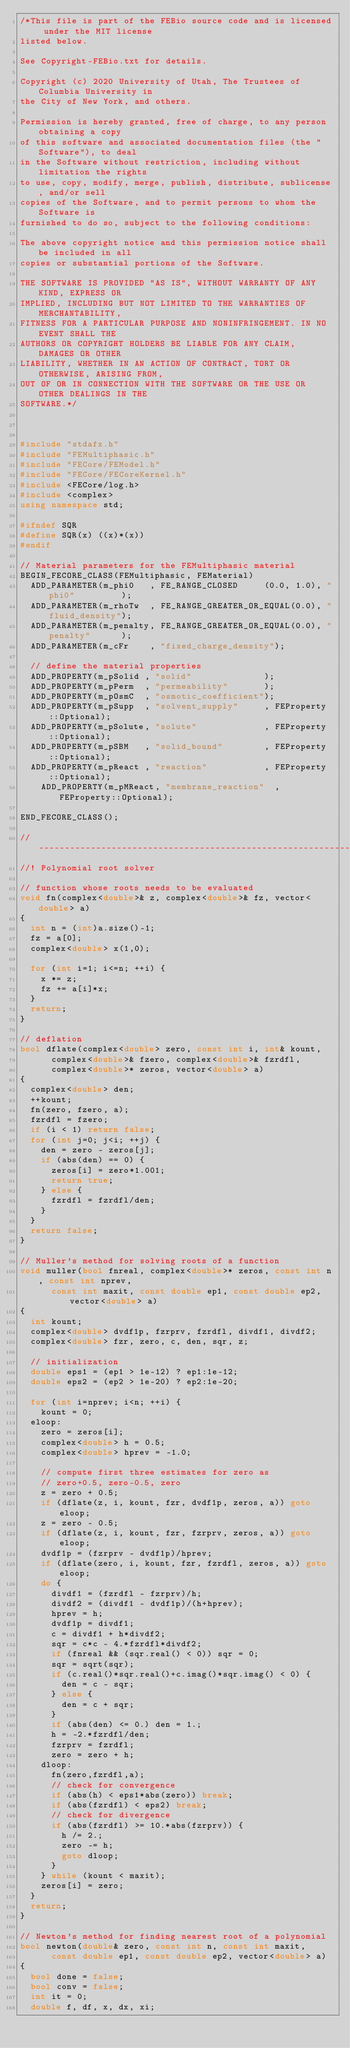<code> <loc_0><loc_0><loc_500><loc_500><_C++_>/*This file is part of the FEBio source code and is licensed under the MIT license
listed below.

See Copyright-FEBio.txt for details.

Copyright (c) 2020 University of Utah, The Trustees of Columbia University in 
the City of New York, and others.

Permission is hereby granted, free of charge, to any person obtaining a copy
of this software and associated documentation files (the "Software"), to deal
in the Software without restriction, including without limitation the rights
to use, copy, modify, merge, publish, distribute, sublicense, and/or sell
copies of the Software, and to permit persons to whom the Software is
furnished to do so, subject to the following conditions:

The above copyright notice and this permission notice shall be included in all
copies or substantial portions of the Software.

THE SOFTWARE IS PROVIDED "AS IS", WITHOUT WARRANTY OF ANY KIND, EXPRESS OR
IMPLIED, INCLUDING BUT NOT LIMITED TO THE WARRANTIES OF MERCHANTABILITY,
FITNESS FOR A PARTICULAR PURPOSE AND NONINFRINGEMENT. IN NO EVENT SHALL THE
AUTHORS OR COPYRIGHT HOLDERS BE LIABLE FOR ANY CLAIM, DAMAGES OR OTHER
LIABILITY, WHETHER IN AN ACTION OF CONTRACT, TORT OR OTHERWISE, ARISING FROM,
OUT OF OR IN CONNECTION WITH THE SOFTWARE OR THE USE OR OTHER DEALINGS IN THE
SOFTWARE.*/



#include "stdafx.h"
#include "FEMultiphasic.h"
#include "FECore/FEModel.h"
#include "FECore/FECoreKernel.h"
#include <FECore/log.h>
#include <complex>
using namespace std;

#ifndef SQR
#define SQR(x) ((x)*(x))
#endif

// Material parameters for the FEMultiphasic material
BEGIN_FECORE_CLASS(FEMultiphasic, FEMaterial)
	ADD_PARAMETER(m_phi0   , FE_RANGE_CLOSED     (0.0, 1.0), "phi0"         );
	ADD_PARAMETER(m_rhoTw  , FE_RANGE_GREATER_OR_EQUAL(0.0), "fluid_density");
	ADD_PARAMETER(m_penalty, FE_RANGE_GREATER_OR_EQUAL(0.0), "penalty"      );
	ADD_PARAMETER(m_cFr    , "fixed_charge_density");

	// define the material properties
	ADD_PROPERTY(m_pSolid , "solid"              );
	ADD_PROPERTY(m_pPerm  , "permeability"       );
	ADD_PROPERTY(m_pOsmC  , "osmotic_coefficient");
	ADD_PROPERTY(m_pSupp  , "solvent_supply"     , FEProperty::Optional);
	ADD_PROPERTY(m_pSolute, "solute"             , FEProperty::Optional);
	ADD_PROPERTY(m_pSBM   , "solid_bound"        , FEProperty::Optional);
	ADD_PROPERTY(m_pReact , "reaction"           , FEProperty::Optional);
    ADD_PROPERTY(m_pMReact, "membrane_reaction"  , FEProperty::Optional);

END_FECORE_CLASS();

//-----------------------------------------------------------------------------
//! Polynomial root solver

// function whose roots needs to be evaluated
void fn(complex<double>& z, complex<double>& fz, vector<double> a)
{
	int n = (int)a.size()-1;
	fz = a[0];
	complex<double> x(1,0);
	
	for (int i=1; i<=n; ++i) {
		x *= z;
		fz += a[i]*x;
	}
	return;
}

// deflation
bool dflate(complex<double> zero, const int i, int& kount,
			complex<double>& fzero, complex<double>& fzrdfl,
			complex<double>* zeros, vector<double> a)
{
	complex<double> den;
	++kount;
	fn(zero, fzero, a);
	fzrdfl = fzero;
	if (i < 1) return false;
	for (int j=0; j<i; ++j) {
		den = zero - zeros[j];
		if (abs(den) == 0) {
			zeros[i] = zero*1.001;
			return true;
		} else {
			fzrdfl = fzrdfl/den;
		}
	}
	return false;
}

// Muller's method for solving roots of a function
void muller(bool fnreal, complex<double>* zeros, const int n, const int nprev,
			const int maxit, const double ep1, const double ep2, vector<double> a)
{
	int kount;
	complex<double> dvdf1p, fzrprv, fzrdfl, divdf1, divdf2;
	complex<double> fzr, zero, c, den, sqr, z;
	
	// initialization
	double eps1 = (ep1 > 1e-12) ? ep1:1e-12;
	double eps2 = (ep2 > 1e-20) ? ep2:1e-20;
	
	for (int i=nprev; i<n; ++i) {
		kount = 0;
	eloop:
		zero = zeros[i];
		complex<double> h = 0.5;
		complex<double> hprev = -1.0;
		
		// compute first three estimates for zero as
		// zero+0.5, zero-0.5, zero
		z = zero + 0.5;
		if (dflate(z, i, kount, fzr, dvdf1p, zeros, a)) goto eloop;
		z = zero - 0.5;
		if (dflate(z, i, kount, fzr, fzrprv, zeros, a)) goto eloop;
		dvdf1p = (fzrprv - dvdf1p)/hprev;
		if (dflate(zero, i, kount, fzr, fzrdfl, zeros, a)) goto eloop;
		do {
			divdf1 = (fzrdfl - fzrprv)/h;
			divdf2 = (divdf1 - dvdf1p)/(h+hprev);
			hprev = h;
			dvdf1p = divdf1;
			c = divdf1 + h*divdf2;
			sqr = c*c - 4.*fzrdfl*divdf2;
			if (fnreal && (sqr.real() < 0)) sqr = 0;
			sqr = sqrt(sqr);
			if (c.real()*sqr.real()+c.imag()*sqr.imag() < 0) {
				den = c - sqr;
			} else {
				den = c + sqr;
			}
			if (abs(den) <= 0.) den = 1.;
			h = -2.*fzrdfl/den;
			fzrprv = fzrdfl;
			zero = zero + h;
		dloop:
			fn(zero,fzrdfl,a);
			// check for convergence
			if (abs(h) < eps1*abs(zero)) break;
			if (abs(fzrdfl) < eps2) break;
			// check for divergence
			if (abs(fzrdfl) >= 10.*abs(fzrprv)) {
				h /= 2.;
				zero -= h;
				goto dloop;
			}
		} while (kount < maxit);
		zeros[i] = zero;
	}
	return;
}

// Newton's method for finding nearest root of a polynomial
bool newton(double& zero, const int n, const int maxit, 
			const double ep1, const double ep2, vector<double> a)
{
	bool done = false;
	bool conv = false;
	int it = 0;
	double f, df, x, dx, xi;</code> 